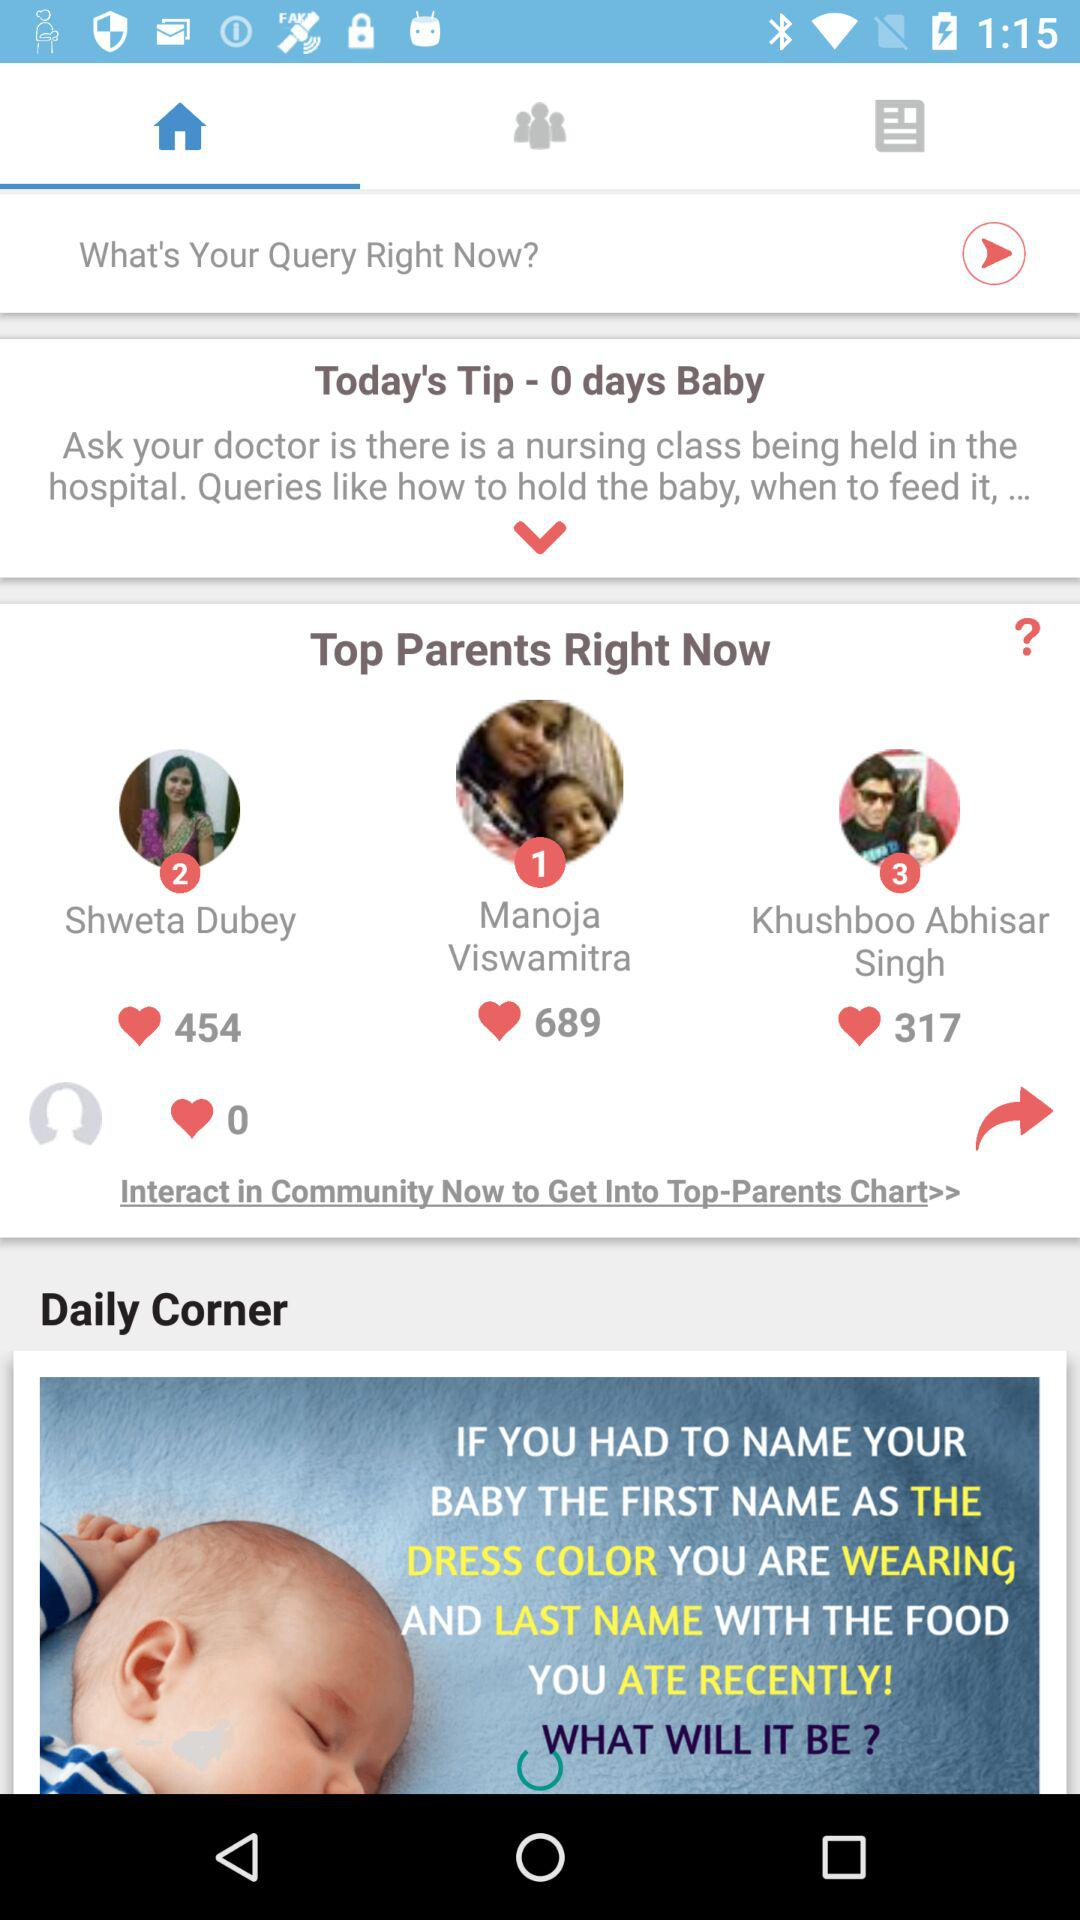How many people are in the top parents chart?
Answer the question using a single word or phrase. 3 